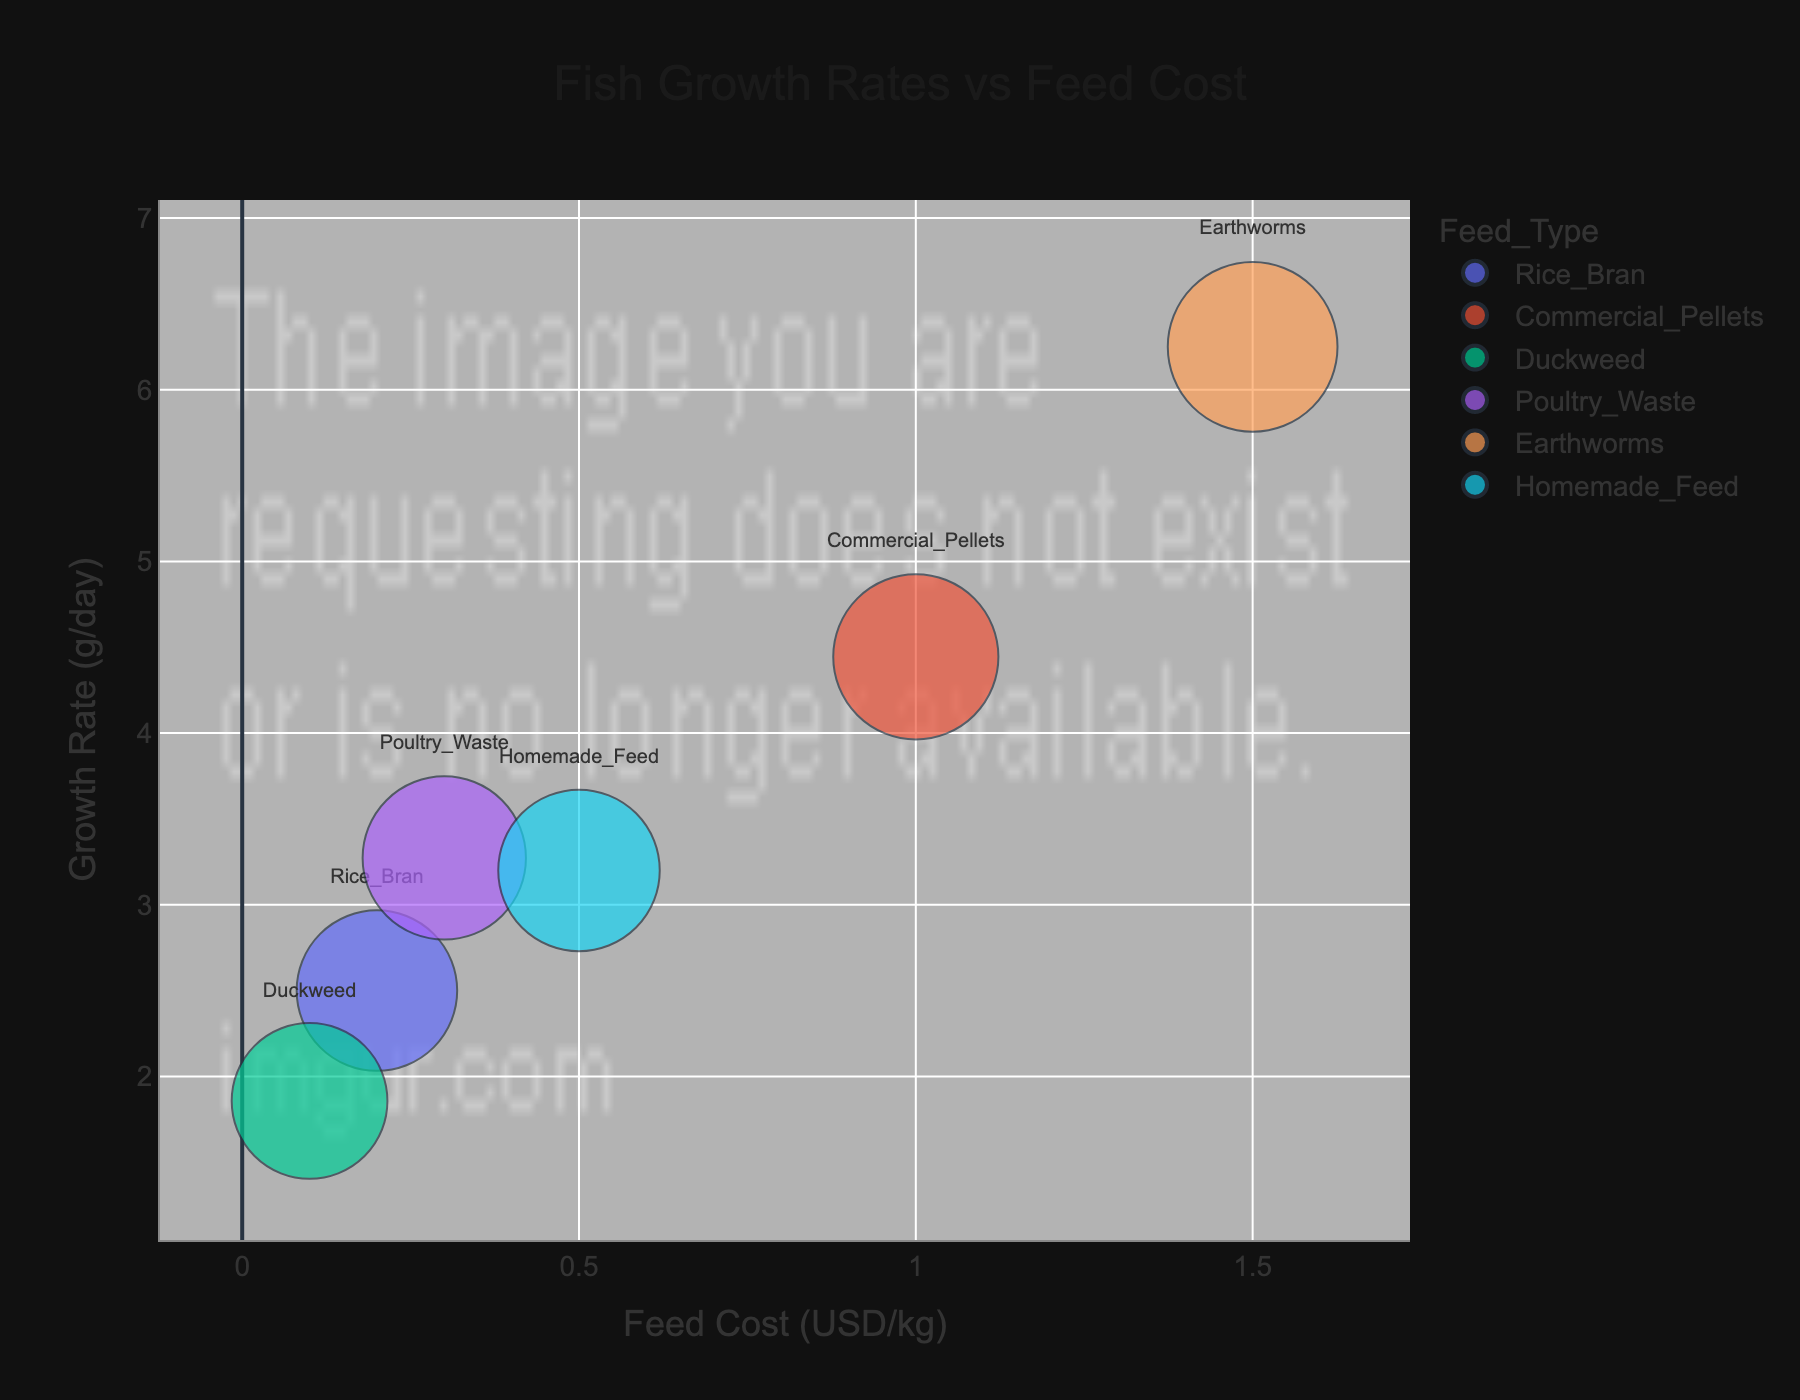What is the title of the figure? The title is clearly displayed at the top center of the figure. It reads 'Fish Growth Rates vs Feed Cost'.
Answer: Fish Growth Rates vs Feed Cost Which feed type has the highest growth rate? From the bubble positions, the 'Earthworms' feed type has the most vertical position, indicating it's the highest growth rate on the y-axis labeled 'Growth Rate (g/day)'.
Answer: Earthworms What is the feed cost for 'Duckweed'? Locate the 'Duckweed' bubble on the chart. It is positioned on the x-axis at the point representing 0.1 USD/kg.
Answer: 0.1 USD/kg Which feed type represents the smallest bubble and what does it signify? The smallest bubble represents 'Duckweed'. Bubble size in this chart represents the 'Survival Rate (%)'. The smaller the bubble, the lower the survival rate.
Answer: Duckweed, lower survival rate Compare the survival rates of 'Rice Bran' and 'Commercial Pellets'. Which is higher and by how much? 'Commercial Pellets' bubble is bigger than 'Rice Bran', as indicated by the size representing their survival rates. From the figure, 'Commercial Pellets' has a survival rate of 90%, while 'Rice Bran' has 85%. The difference is 90% - 85% = 5%.
Answer: Commercial Pellets, 5% What is the average growth rate across all feeds? Growth rates for the feeds are: 2.5 (Rice Bran), 4.44 (Commercial Pellets), 1.86 (Duckweed), 3.27 (Poultry Waste), 6.25 (Earthworms), 3.2 (Homemade Feed). The sum is 21.52. There are 6 different feeds, so the average growth rate is 21.52 / 6 = 3.59 g/day.
Answer: 3.59 g/day Which feed type has the best combination of high growth rate and high survival rate? Look for a large bubble positioned high on the y-axis. 'Earthworms' is a large bubble positioned highest, indicating both high growth rate and survival rate.
Answer: Earthworms How do 'Poultry Waste' and 'Homemade Feed' compare in terms of feed cost and growth rate? 'Poultry Waste' has a feed cost of 0.3 USD/kg and a growth rate around 3.27 g/day. 'Homemade Feed' has a feed cost of 0.5 USD/kg and a growth rate around 3.2 g/day. 'Poultry Waste' is cheaper and has a slightly higher growth rate.
Answer: Poultry Waste is cheaper and has a slightly higher growth rate What insight can you get by comparing feed costs and growth rates? Generally, higher feed costs are associated with higher growth rates, except for 'Duckweed' which is cheap yet has a low growth rate.
Answer: Higher feed costs generally lead to higher growth rates What is the survival rate for 'Earthworms' and what does its bubble size indicate? 'Earthworms' has a survival rate of 95%. Since its bubble is the largest on the chart, indicating the highest survival rate among all feed types.
Answer: 95%, highest survival rate 